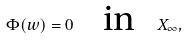<formula> <loc_0><loc_0><loc_500><loc_500>\Phi ( w ) = 0 \text { } \text { } \text { } \text { in } \text { } \text { } X _ { \infty } ,</formula> 